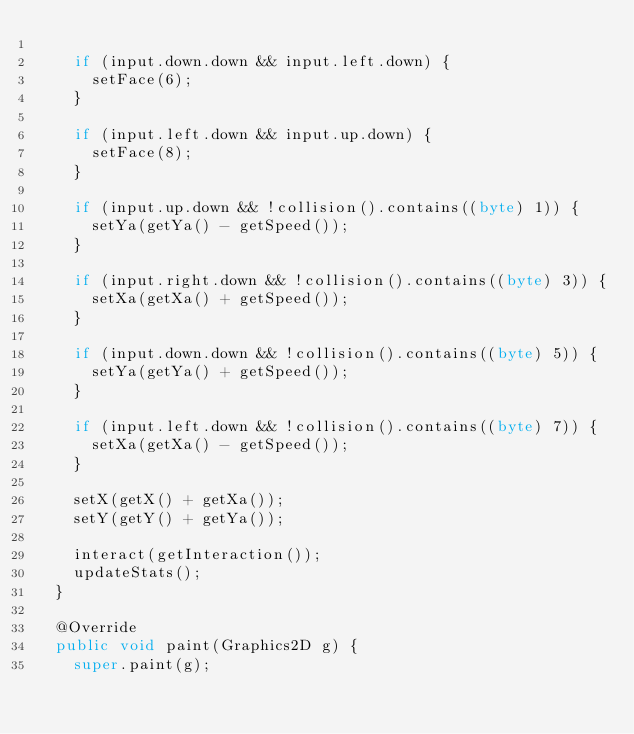Convert code to text. <code><loc_0><loc_0><loc_500><loc_500><_Java_>		
		if (input.down.down && input.left.down) {
			setFace(6);
		}
		
		if (input.left.down && input.up.down) {
			setFace(8);
		}
		
		if (input.up.down && !collision().contains((byte) 1)) {
			setYa(getYa() - getSpeed());
		}
		
		if (input.right.down && !collision().contains((byte) 3)) {
			setXa(getXa() + getSpeed());
		}
		
		if (input.down.down && !collision().contains((byte) 5)) {
			setYa(getYa() + getSpeed());
		}
		
		if (input.left.down && !collision().contains((byte) 7)) {
			setXa(getXa() - getSpeed());
		}
		
		setX(getX() + getXa());
		setY(getY() + getYa());
		
		interact(getInteraction());
		updateStats();
	}
	
	@Override
	public void paint(Graphics2D g) {
		super.paint(g);
		</code> 